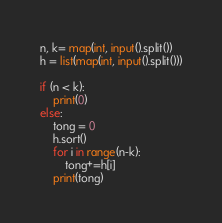<code> <loc_0><loc_0><loc_500><loc_500><_Python_>n, k= map(int, input().split())
h = list(map(int, input().split()))

if (n < k):
    print(0)
else:
    tong = 0
    h.sort()
    for i in range(n-k):
        tong+=h[i]
    print(tong)        </code> 